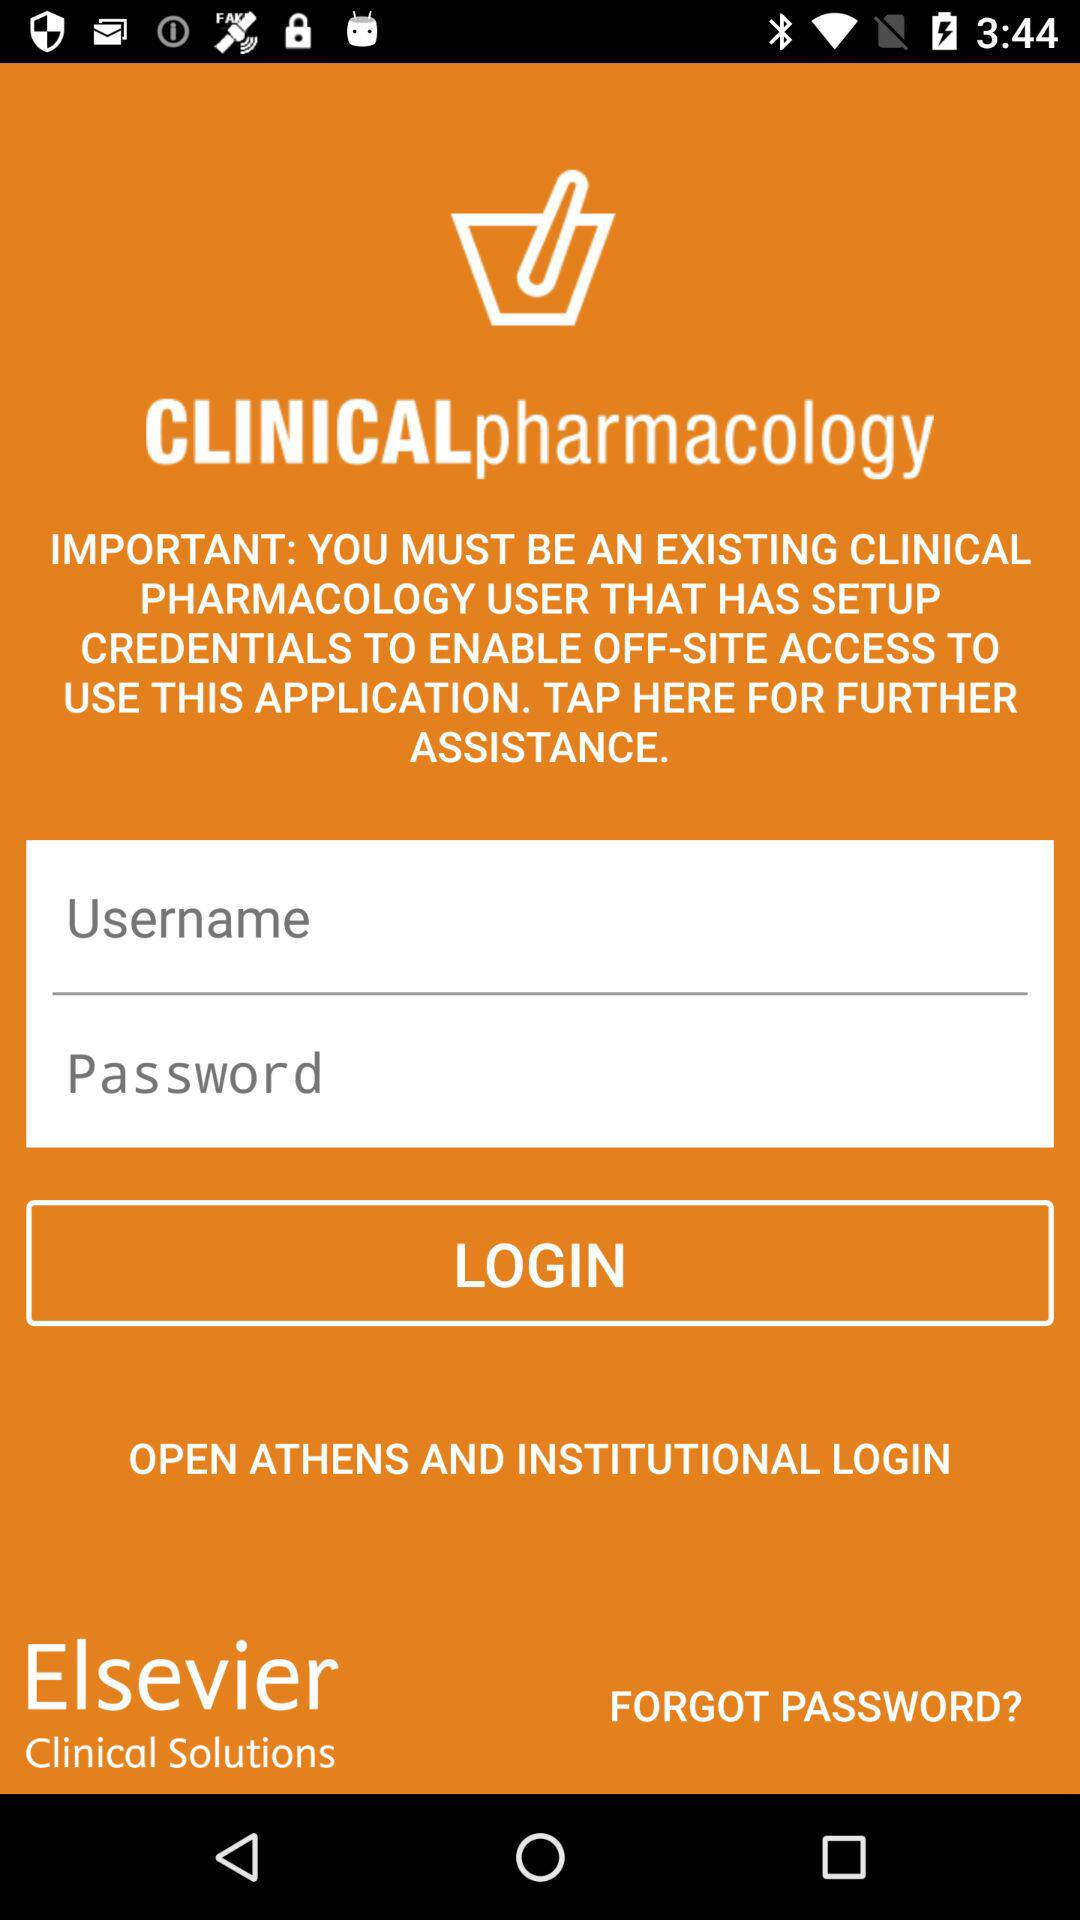What is the name of the application? The name of the application is "CLINICAL pharmacology". 